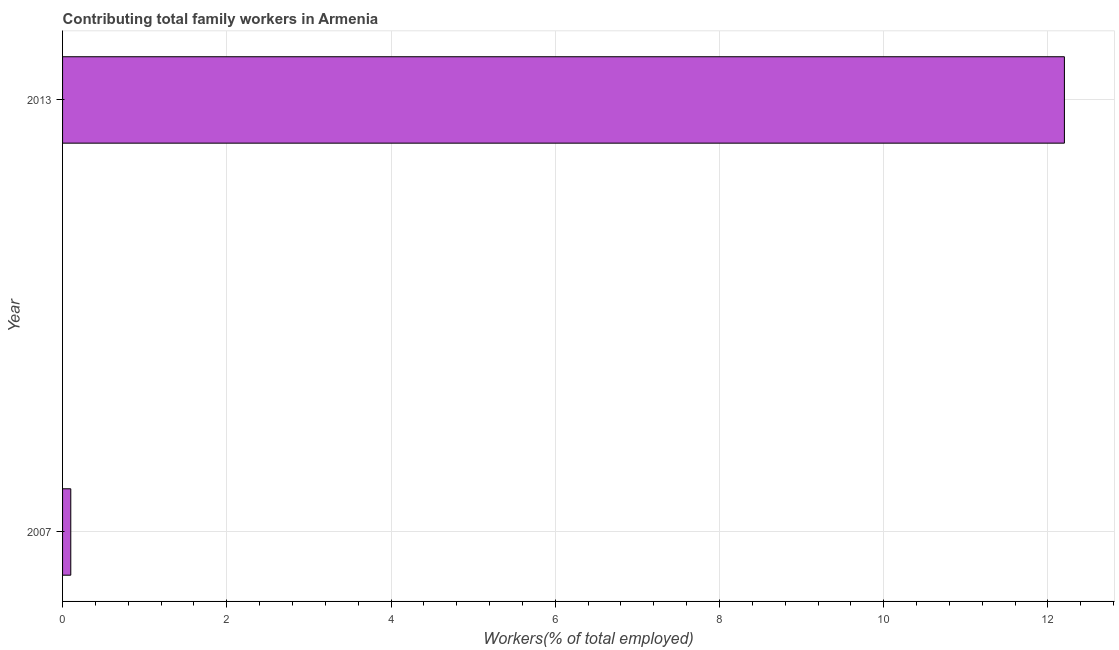Does the graph contain grids?
Give a very brief answer. Yes. What is the title of the graph?
Keep it short and to the point. Contributing total family workers in Armenia. What is the label or title of the X-axis?
Offer a terse response. Workers(% of total employed). What is the contributing family workers in 2013?
Your answer should be very brief. 12.2. Across all years, what is the maximum contributing family workers?
Offer a terse response. 12.2. Across all years, what is the minimum contributing family workers?
Your response must be concise. 0.1. In which year was the contributing family workers maximum?
Your response must be concise. 2013. In which year was the contributing family workers minimum?
Give a very brief answer. 2007. What is the sum of the contributing family workers?
Ensure brevity in your answer.  12.3. What is the average contributing family workers per year?
Make the answer very short. 6.15. What is the median contributing family workers?
Provide a succinct answer. 6.15. In how many years, is the contributing family workers greater than 2.4 %?
Ensure brevity in your answer.  1. What is the ratio of the contributing family workers in 2007 to that in 2013?
Ensure brevity in your answer.  0.01. How many bars are there?
Make the answer very short. 2. What is the difference between two consecutive major ticks on the X-axis?
Ensure brevity in your answer.  2. What is the Workers(% of total employed) in 2007?
Your answer should be compact. 0.1. What is the Workers(% of total employed) of 2013?
Offer a very short reply. 12.2. What is the difference between the Workers(% of total employed) in 2007 and 2013?
Your answer should be very brief. -12.1. What is the ratio of the Workers(% of total employed) in 2007 to that in 2013?
Your answer should be very brief. 0.01. 